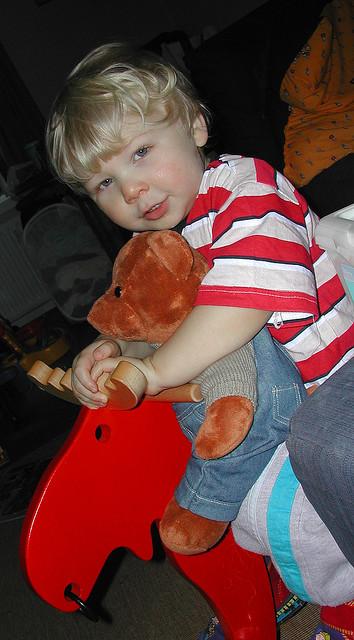Is the boy on the floor?
Give a very brief answer. No. What animal is the boy riding on?
Short answer required. Moose. What is pink?
Be succinct. Blanket. Is the boy smiling?
Be succinct. Yes. What is hugging the bear?
Write a very short answer. Boy. What color are the feet?
Write a very short answer. Brown. 